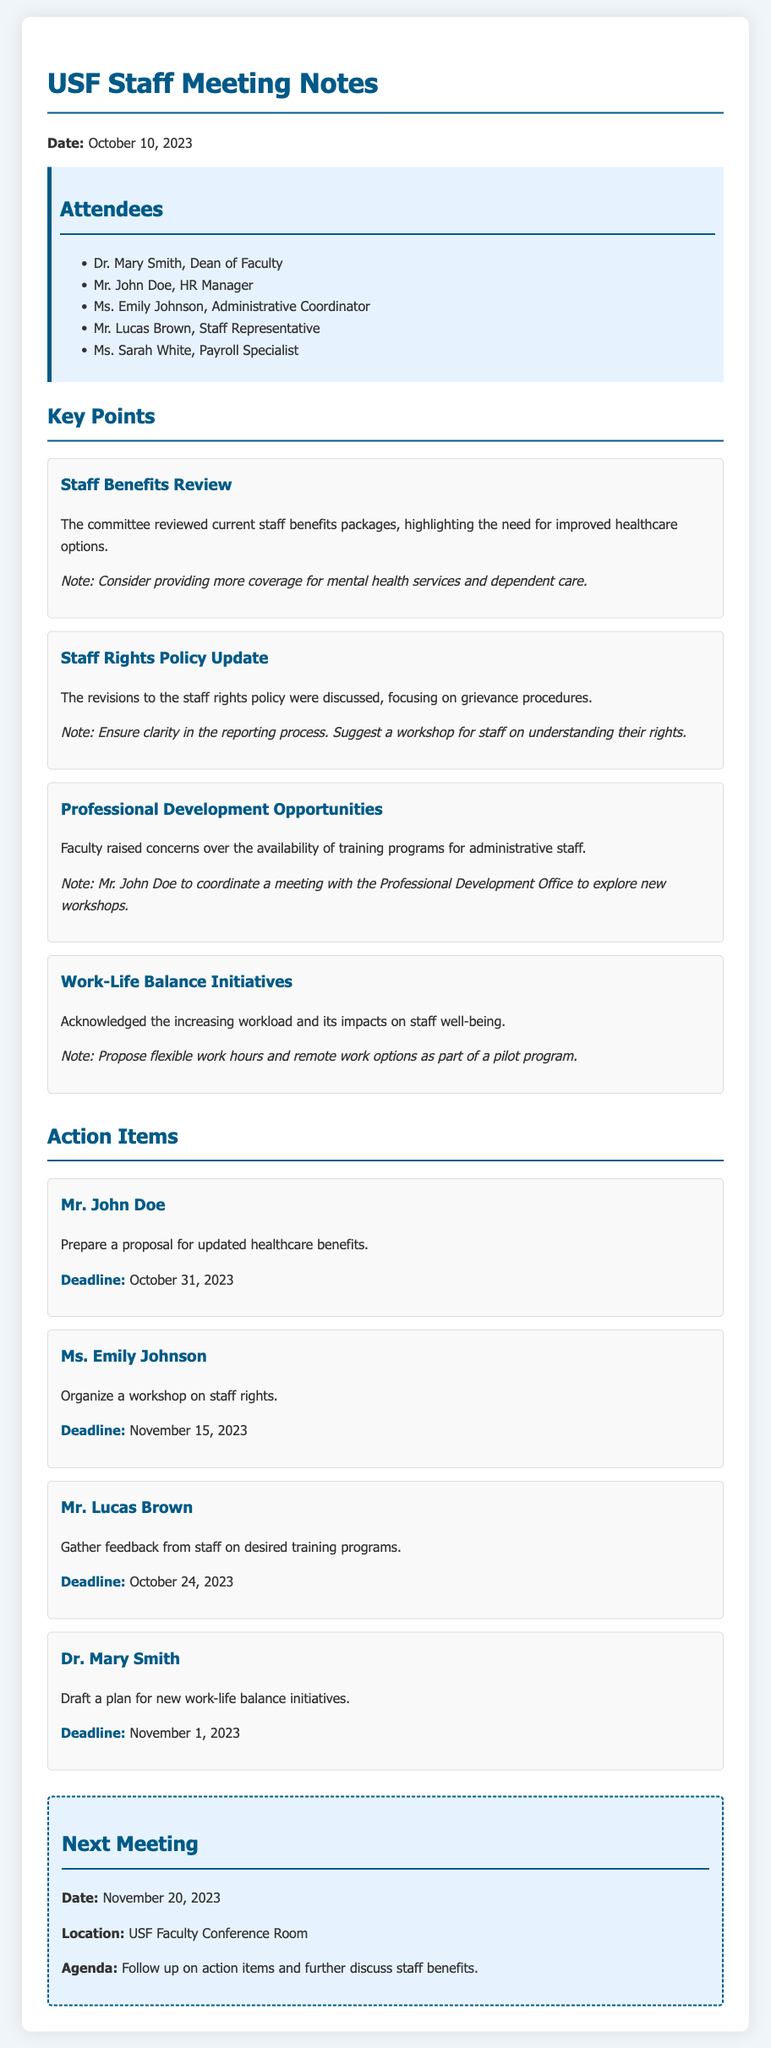What is the date of the meeting? The date of the meeting is mentioned at the beginning of the document.
Answer: October 10, 2023 Who is the HR Manager? The document lists the attendees, where the HR Manager's name is mentioned.
Answer: Mr. John Doe What is the deadline for the proposal on updated healthcare benefits? The deadline is specifically noted in the action items section assigned to Mr. John Doe.
Answer: October 31, 2023 What was discussed regarding staff rights? The key points section includes a discussion on revisions to staff rights policy.
Answer: Grievance procedures Which staff member will organize a workshop on staff rights? The action items specify that Ms. Emily Johnson is responsible for organizing this workshop.
Answer: Ms. Emily Johnson What initiative was suggested to address work-life balance? The document details an initiative proposed to improve work-life balance, noted in the key points.
Answer: Flexible work hours Who will gather feedback from staff on training programs? The document states that Mr. Lucas Brown is assigned this task in the action items section.
Answer: Mr. Lucas Brown When is the next meeting scheduled? The next meeting date is provided at the end of the document.
Answer: November 20, 2023 What is the focus of the next meeting's agenda? The agenda for the next meeting is outlined in the next meeting section of the document.
Answer: Follow up on action items and further discuss staff benefits 